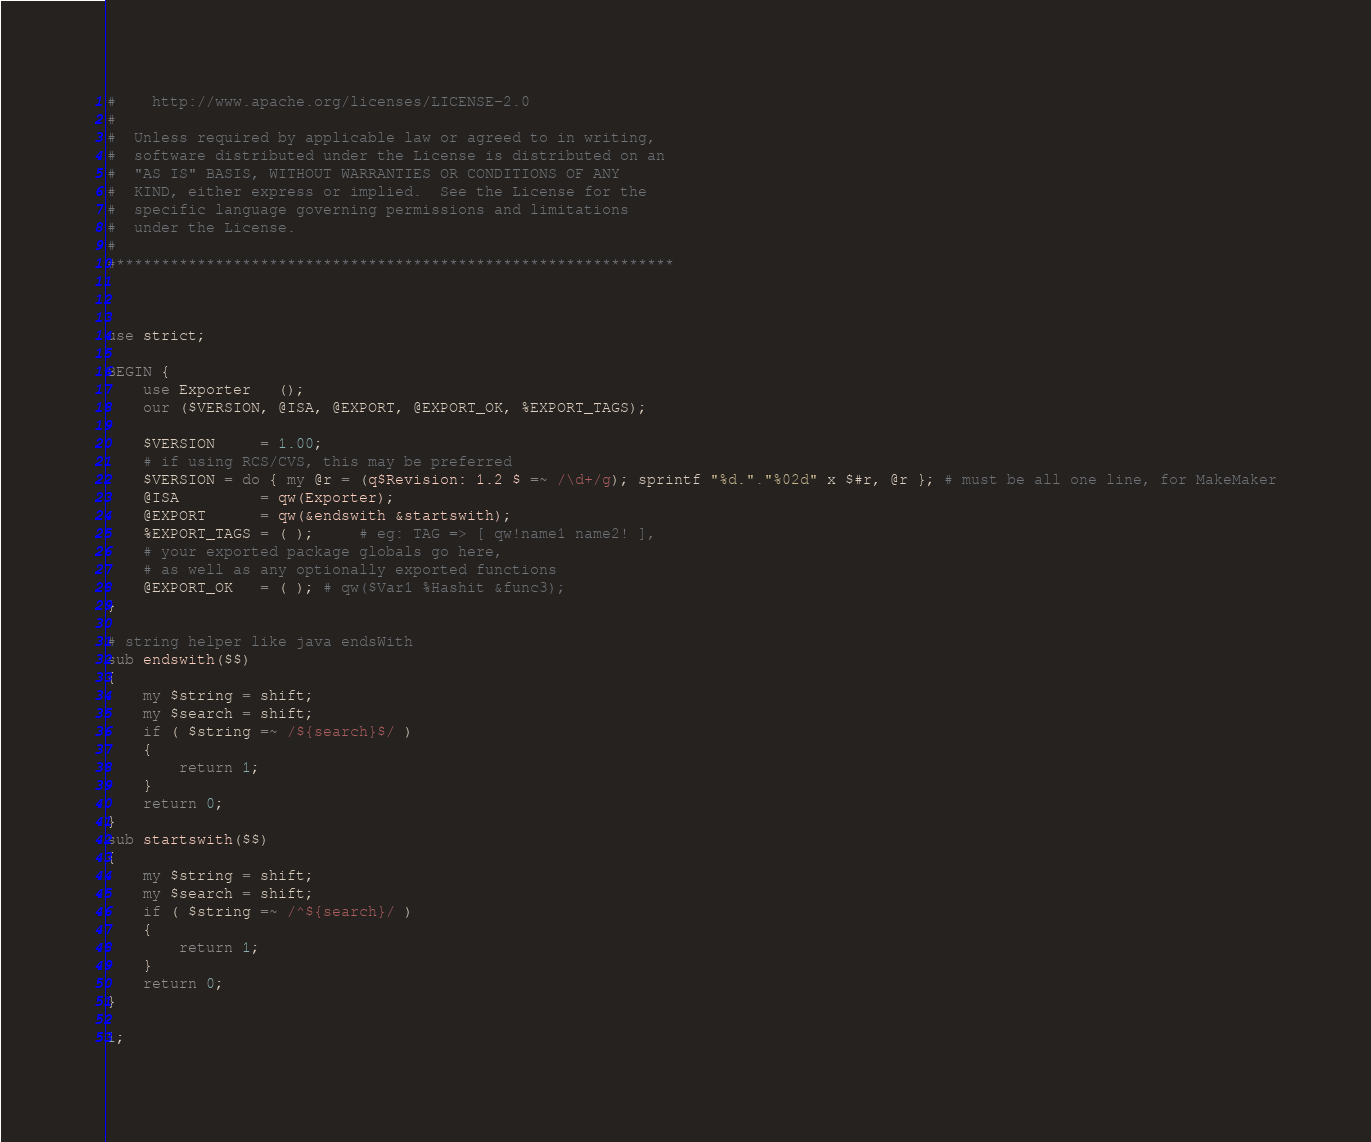Convert code to text. <code><loc_0><loc_0><loc_500><loc_500><_Perl_>#    http://www.apache.org/licenses/LICENSE-2.0
#  
#  Unless required by applicable law or agreed to in writing,
#  software distributed under the License is distributed on an
#  "AS IS" BASIS, WITHOUT WARRANTIES OR CONDITIONS OF ANY
#  KIND, either express or implied.  See the License for the
#  specific language governing permissions and limitations
#  under the License.
#  
#**************************************************************



use strict;

BEGIN {
    use Exporter   ();
    our ($VERSION, @ISA, @EXPORT, @EXPORT_OK, %EXPORT_TAGS);

    $VERSION     = 1.00;
    # if using RCS/CVS, this may be preferred
    $VERSION = do { my @r = (q$Revision: 1.2 $ =~ /\d+/g); sprintf "%d."."%02d" x $#r, @r }; # must be all one line, for MakeMaker
    @ISA         = qw(Exporter);
    @EXPORT      = qw(&endswith &startswith);
    %EXPORT_TAGS = ( );     # eg: TAG => [ qw!name1 name2! ],
    # your exported package globals go here,
    # as well as any optionally exported functions
    @EXPORT_OK   = ( ); # qw($Var1 %Hashit &func3);
}

# string helper like java endsWith
sub endswith($$)
{
    my $string = shift;
    my $search = shift;
    if ( $string =~ /${search}$/ )
    {
        return 1;
    }
    return 0;
}
sub startswith($$)
{
    my $string = shift;
    my $search = shift;
    if ( $string =~ /^${search}/ )
    {
        return 1;
    }
    return 0;
}

1;
</code> 